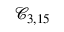Convert formula to latex. <formula><loc_0><loc_0><loc_500><loc_500>\mathcal { C } _ { 3 , 1 5 }</formula> 